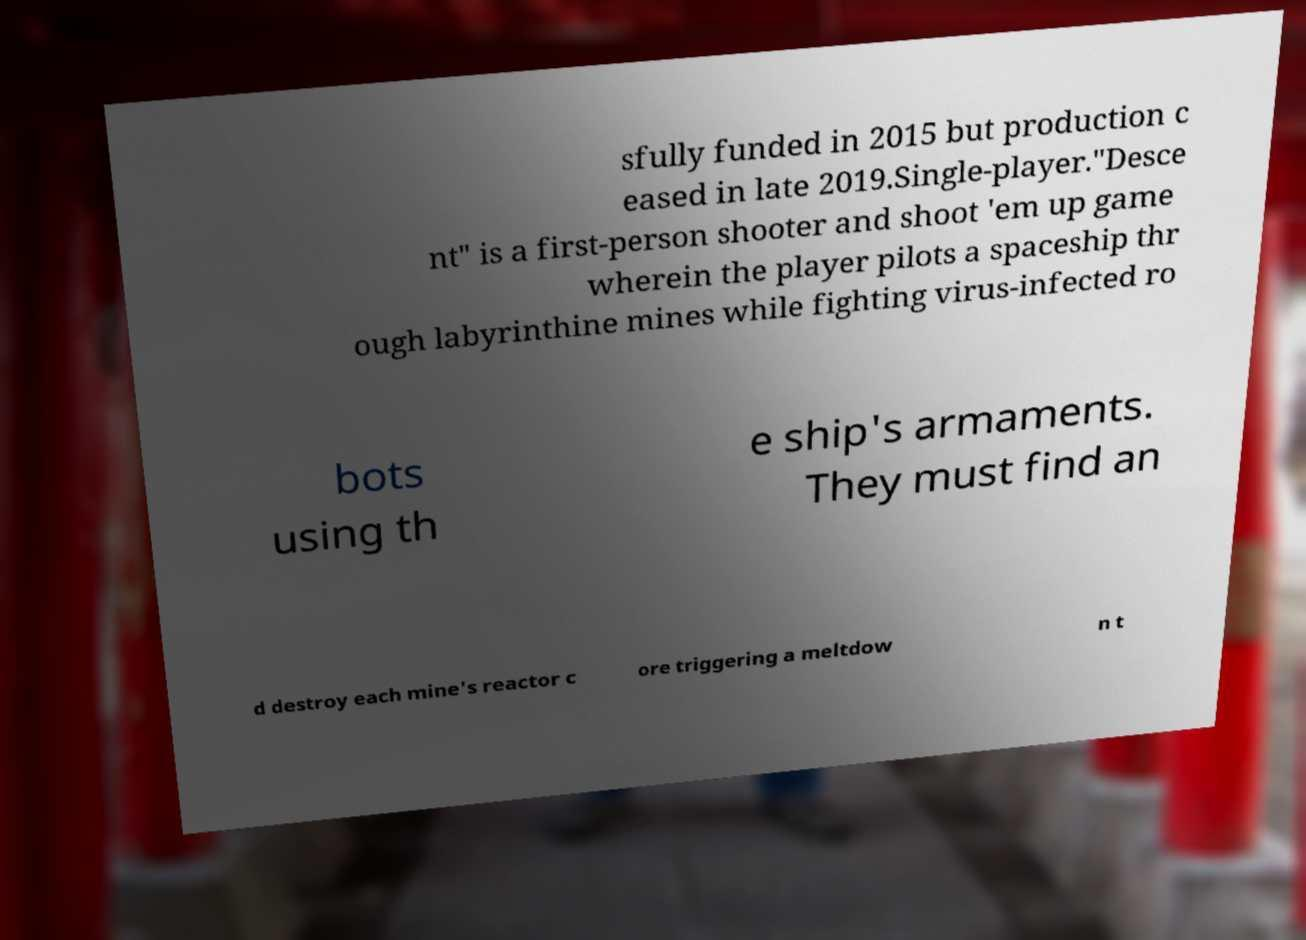I need the written content from this picture converted into text. Can you do that? sfully funded in 2015 but production c eased in late 2019.Single-player."Desce nt" is a first-person shooter and shoot 'em up game wherein the player pilots a spaceship thr ough labyrinthine mines while fighting virus-infected ro bots using th e ship's armaments. They must find an d destroy each mine's reactor c ore triggering a meltdow n t 